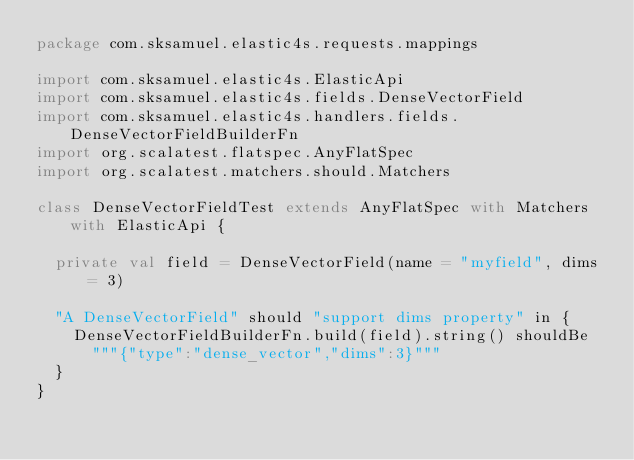Convert code to text. <code><loc_0><loc_0><loc_500><loc_500><_Scala_>package com.sksamuel.elastic4s.requests.mappings

import com.sksamuel.elastic4s.ElasticApi
import com.sksamuel.elastic4s.fields.DenseVectorField
import com.sksamuel.elastic4s.handlers.fields.DenseVectorFieldBuilderFn
import org.scalatest.flatspec.AnyFlatSpec
import org.scalatest.matchers.should.Matchers

class DenseVectorFieldTest extends AnyFlatSpec with Matchers with ElasticApi {

  private val field = DenseVectorField(name = "myfield", dims = 3)

  "A DenseVectorField" should "support dims property" in {
    DenseVectorFieldBuilderFn.build(field).string() shouldBe
      """{"type":"dense_vector","dims":3}"""
  }
}
</code> 